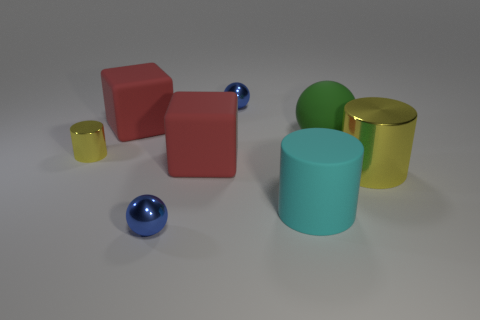Add 1 big rubber cylinders. How many objects exist? 9 Subtract all cylinders. How many objects are left? 5 Add 6 small yellow metallic cylinders. How many small yellow metallic cylinders are left? 7 Add 1 tiny yellow cylinders. How many tiny yellow cylinders exist? 2 Subtract 0 gray spheres. How many objects are left? 8 Subtract all big yellow metal cylinders. Subtract all tiny purple metallic cylinders. How many objects are left? 7 